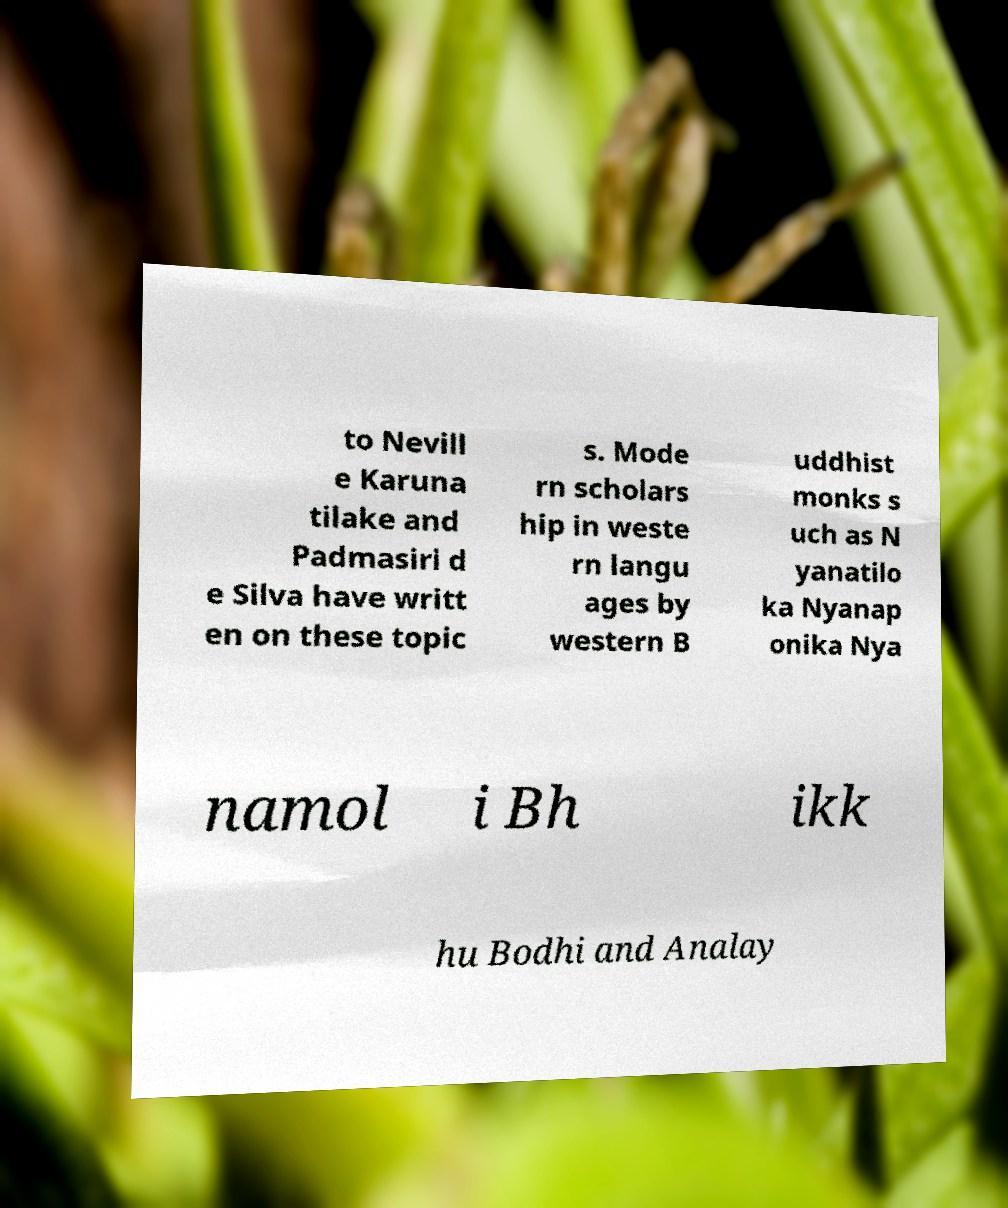Please identify and transcribe the text found in this image. to Nevill e Karuna tilake and Padmasiri d e Silva have writt en on these topic s. Mode rn scholars hip in weste rn langu ages by western B uddhist monks s uch as N yanatilo ka Nyanap onika Nya namol i Bh ikk hu Bodhi and Analay 